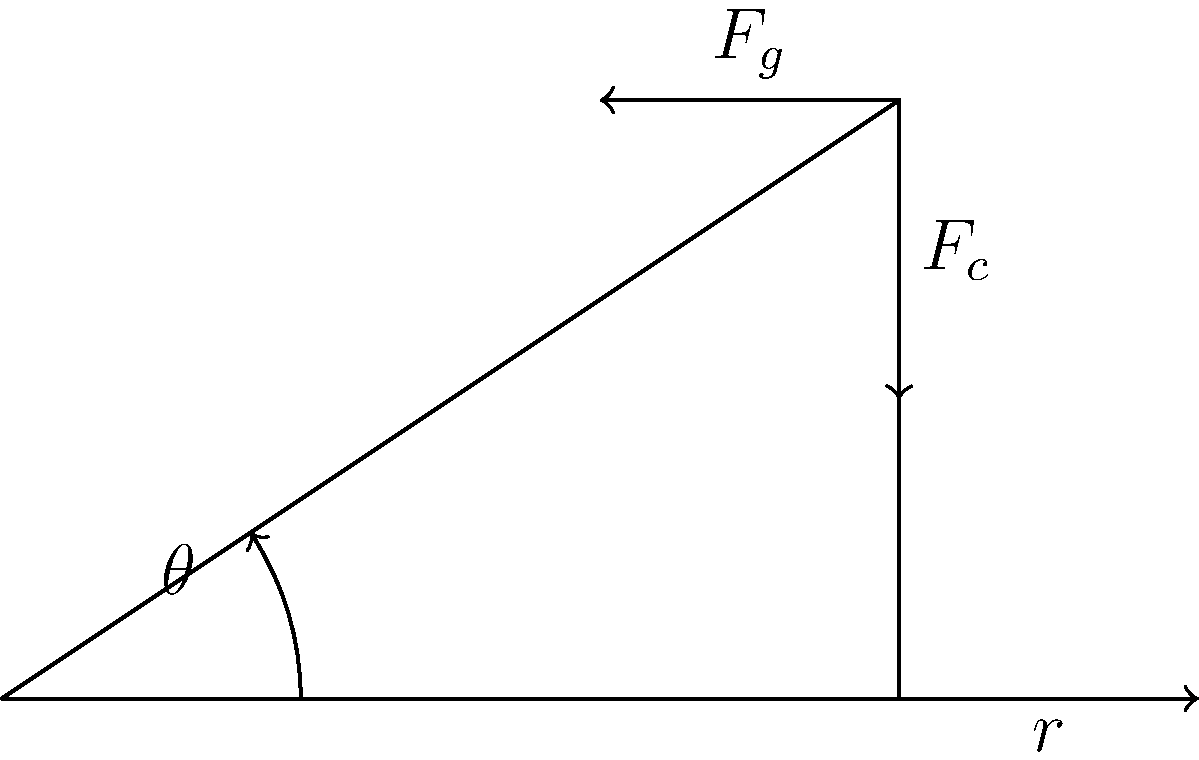In motorcycle speedway, the track's banked turns are crucial for maintaining high speeds. Consider a turn with a radius of 50 meters where a rider travels at 20 m/s. Given that the coefficient of friction between the tires and the track is 0.6, what should be the angle of the banked turn to allow the rider to navigate it safely without relying on friction? (Use $g = 9.8$ m/s²) To solve this problem, we'll follow these steps:

1) The forces acting on the motorcycle are:
   - Centripetal force ($F_c$)
   - Gravity ($F_g$)
   - Normal force from the track ($N$)

2) For the rider to navigate the turn without relying on friction, the normal force must provide the entire centripetal force.

3) The centripetal force is given by:
   $$F_c = \frac{mv^2}{r}$$
   where $m$ is mass, $v$ is velocity, and $r$ is radius.

4) The component of the normal force providing centripetal force is $N \sin \theta$, where $\theta$ is the angle of the bank.

5) The component of the normal force balancing gravity is $N \cos \theta$.

6) We can set up the equation:
   $$N \sin \theta = \frac{mv^2}{r}$$

7) We also know that $N \cos \theta = mg$

8) Dividing these equations:
   $$\frac{N \sin \theta}{N \cos \theta} = \frac{v^2}{rg}$$

9) This simplifies to:
   $$\tan \theta = \frac{v^2}{rg}$$

10) Plugging in our values:
    $$\tan \theta = \frac{(20 \text{ m/s})^2}{(50 \text{ m})(9.8 \text{ m/s}^2)} = 0.8163$$

11) Taking the inverse tangent:
    $$\theta = \tan^{-1}(0.8163) = 39.2°$$

Therefore, the angle of the banked turn should be approximately 39.2°.
Answer: $39.2°$ 